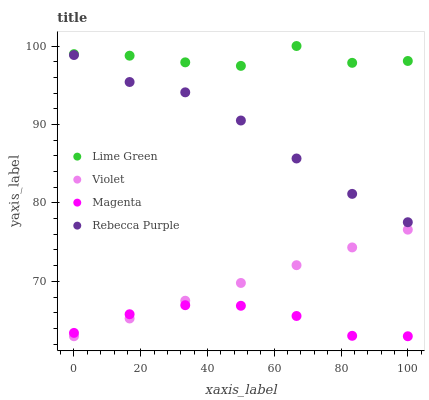Does Magenta have the minimum area under the curve?
Answer yes or no. Yes. Does Lime Green have the maximum area under the curve?
Answer yes or no. Yes. Does Rebecca Purple have the minimum area under the curve?
Answer yes or no. No. Does Rebecca Purple have the maximum area under the curve?
Answer yes or no. No. Is Violet the smoothest?
Answer yes or no. Yes. Is Lime Green the roughest?
Answer yes or no. Yes. Is Rebecca Purple the smoothest?
Answer yes or no. No. Is Rebecca Purple the roughest?
Answer yes or no. No. Does Magenta have the lowest value?
Answer yes or no. Yes. Does Rebecca Purple have the lowest value?
Answer yes or no. No. Does Lime Green have the highest value?
Answer yes or no. Yes. Does Rebecca Purple have the highest value?
Answer yes or no. No. Is Magenta less than Rebecca Purple?
Answer yes or no. Yes. Is Rebecca Purple greater than Violet?
Answer yes or no. Yes. Does Violet intersect Magenta?
Answer yes or no. Yes. Is Violet less than Magenta?
Answer yes or no. No. Is Violet greater than Magenta?
Answer yes or no. No. Does Magenta intersect Rebecca Purple?
Answer yes or no. No. 